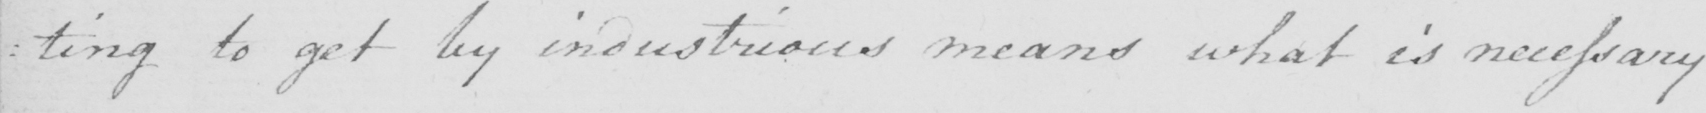Can you read and transcribe this handwriting? : ting to get by industrious means what is necessary 